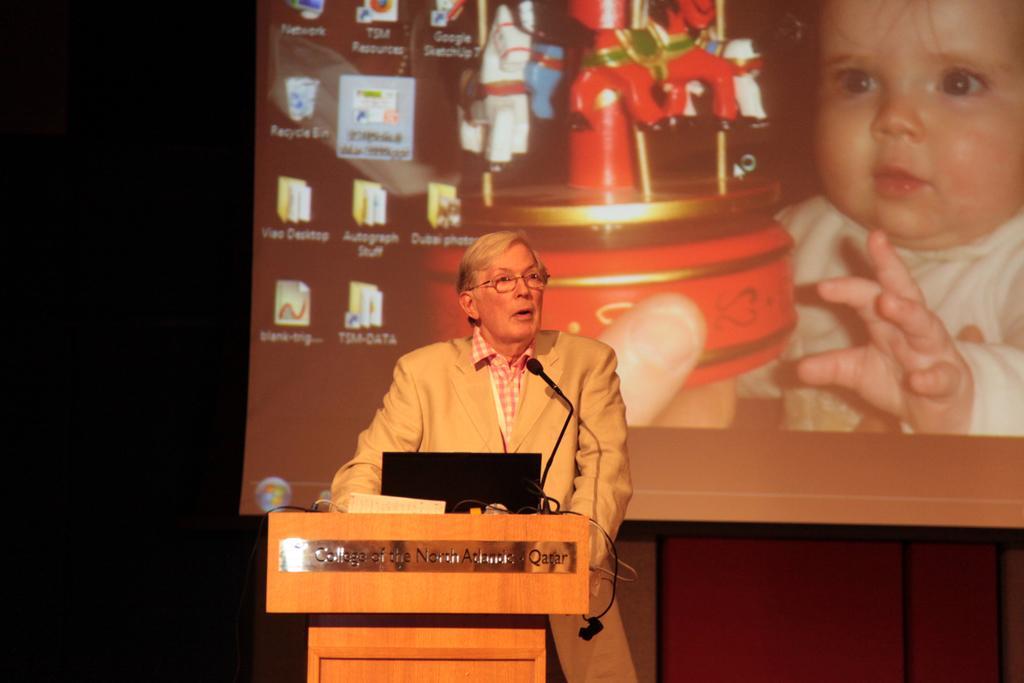Describe this image in one or two sentences. In this picture we can observe a person wearing a coat and standing near the podium. There is a laptop and a mic on the podium. In the background we can observe a projector display screen in which there is a baby and a toy. 